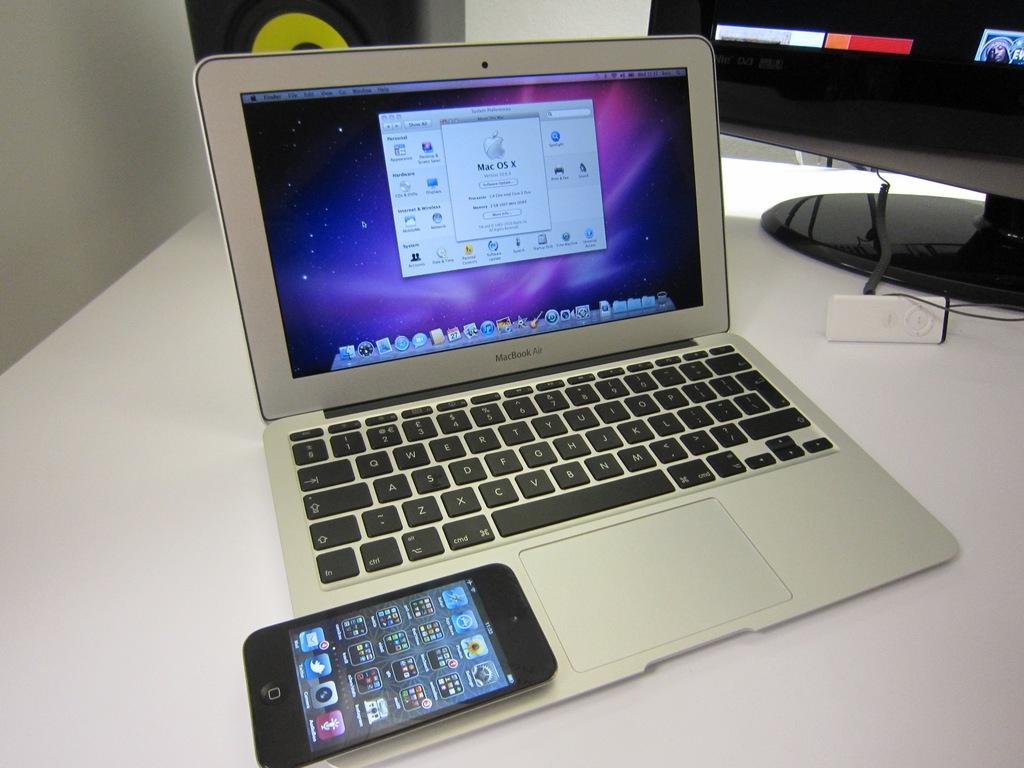What brand of computer is this?
Make the answer very short. Macbook. 